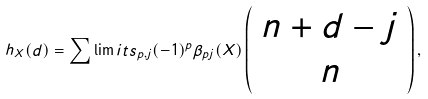Convert formula to latex. <formula><loc_0><loc_0><loc_500><loc_500>h _ { X } ( d ) = \mathop \sum \lim i t s _ { p , j } ( - 1 ) ^ { p } \beta _ { p j } ( X ) \left ( \begin{array} { c } { n + d - j } \\ n \end{array} \right ) ,</formula> 